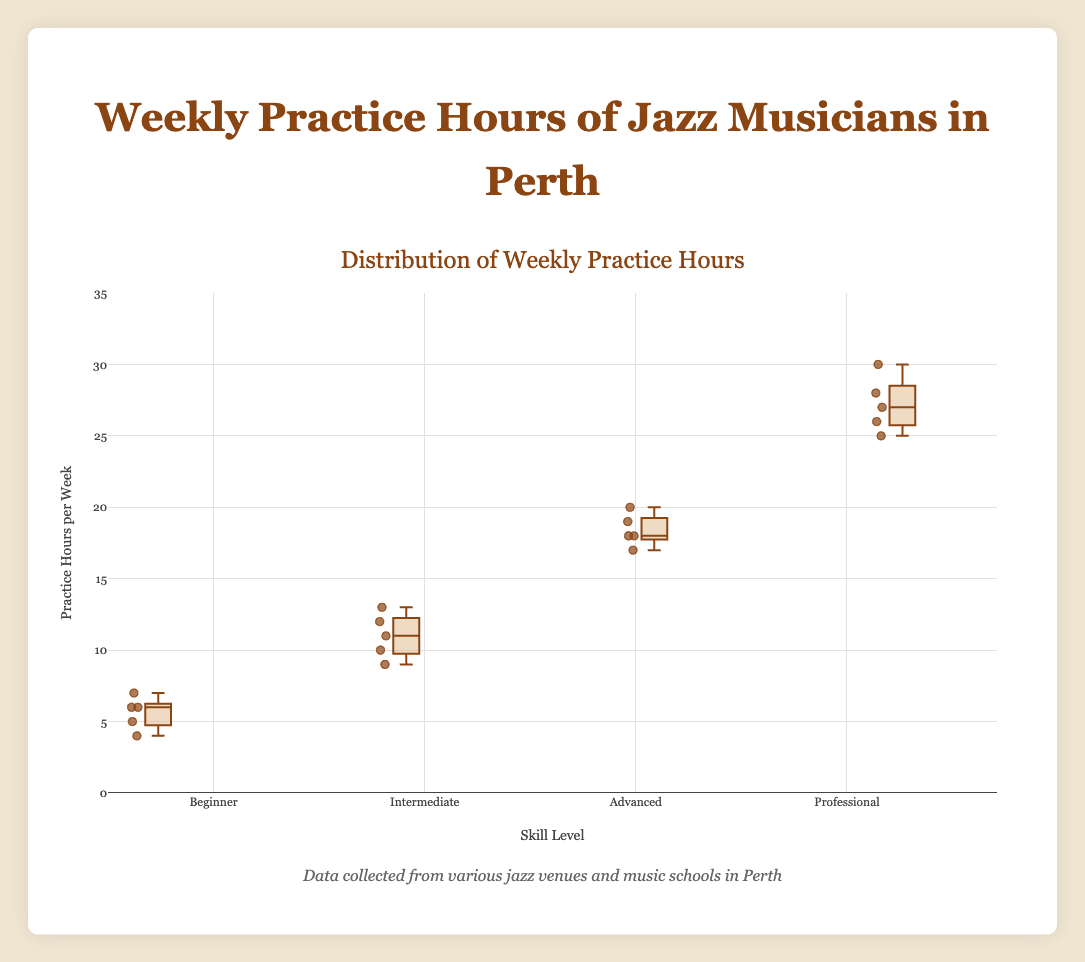What is the median practice hours per week for professional jazz musicians? The median is the middle value when the numbers are arranged in order. For professionals, the hours are (25, 26, 27, 28, 30). The median is the middle value, which is 27.
Answer: 27 Which skill level has the widest range of practice hours per week? The range is the difference between the maximum and minimum values in each group. Beginners (7-4=3), Intermediate (13-9=4), Advanced (20-17=3), Professional (30-25=5). Professionals have the widest range (5 hours).
Answer: Professional What is the upper quartile (Q3) of practice hours for intermediate musicians? To find Q3, we take the median of the upper half of the data. The sorted hours for intermediates are (9, 10, 11, 12, 13). The upper half is (11, 12, 13). The median is 12.
Answer: 12 Compare the median practice hours of beginners and advanced musicians. Which is higher? The median value is the middle value when ordered. Beginners’ hours are (4, 5, 6, 6, 7), median: 6. Advanced hours are (17, 18, 18, 19, 20), median: 18. 18 is higher than 6.
Answer: Advanced Are there any outliers in the practice hours for any skill level? Outliers are typically detected as values significantly different from the rest of the data. Here, all values are close to others within their groups and no extreme values are visible.
Answer: No outliers What is the interquartile range (IQR) for advanced musicians? IQR is calculated as Q3 - Q1. For advanced musicians, Q3 is 19 and Q1 is 18. For the sorted hours (17, 18, 18, 19, 20), IQR = 19-18 = 1.
Answer: 1 Which skill level shows the most consistency in practice hours (smallest spread)? The spread can be observed through the range and box size in the plot. Beginners (Range=3), Intermediate (Range=4), Advanced (Range=3), Professional (Range=5). Beginners and Advanced have the smallest spread.
Answer: Beginners and Advanced How many data points represent the professional skill level? Count the number of musicians listed under the professional group. There are 5 musicians listed.
Answer: 5 Which skill level has the highest median practice hours? Check the middle value for each skill level: Beginners (6), Intermediate (11), Advanced (18), Professional (27). The highest median is for professionals.
Answer: Professional 